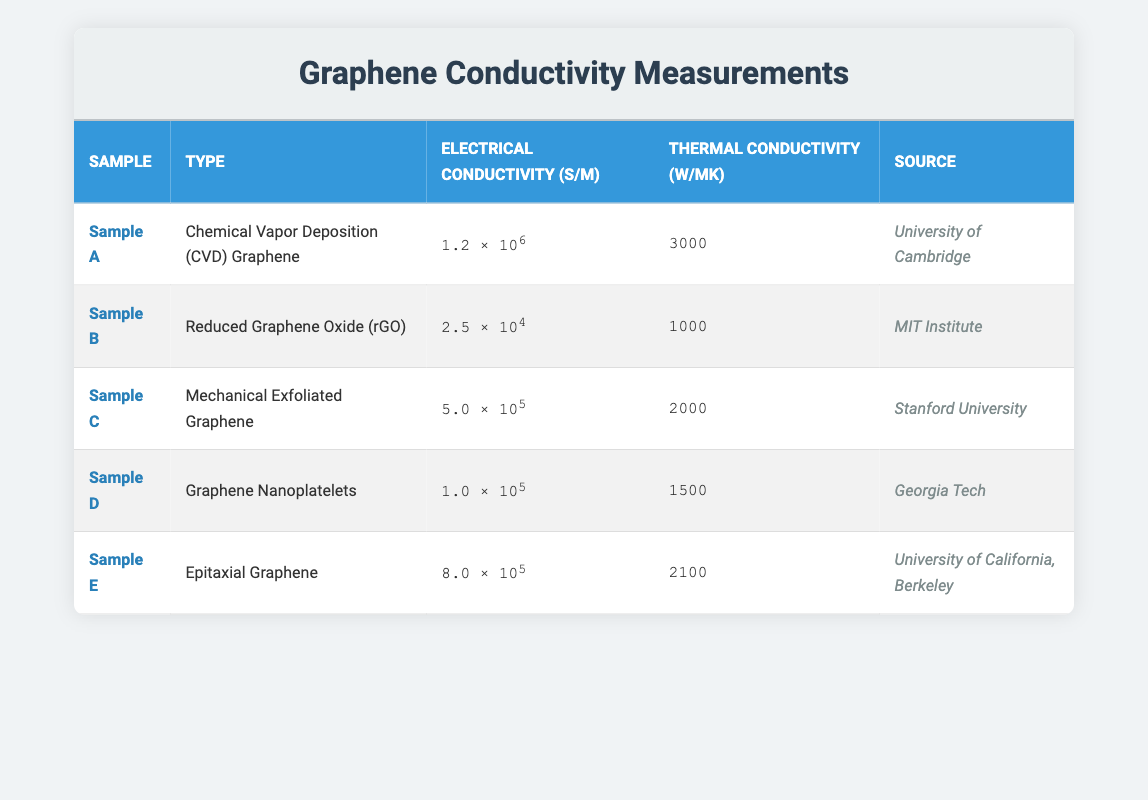What is the electrical conductivity of Sample A? The table shows the electrical conductivity value for Sample A listed as "1.2 × 10⁶ S/m."
Answer: 1.2 × 10⁶ S/m Which sample has the highest thermal conductivity? By comparing the thermal conductivity values of all samples, Sample A has a value of 3000 W/mK, which is higher than the values of the other samples.
Answer: Sample A Is the electrical conductivity of Reduced Graphene Oxide greater than 1.0 × 10⁵ S/m? The table shows that the electrical conductivity for Reduced Graphene Oxide (Sample B) is 2.5 × 10⁴ S/m, which is less than 1.0 × 10⁵ S/m.
Answer: No What is the average electrical conductivity of all samples? To calculate the average, we sum the electrical conductivities: (1.2e6 + 2.5e4 + 5.0e5 + 1.0e5 + 8.0e5) = 2.42e6. There are 5 samples, so the average is 2.42e6 / 5 = 484000 S/m.
Answer: 484000 S/m Does any sample have both electrical conductivity and thermal conductivity above 2000? By checking the values, only Sample A has electrical conductivity of 1.2e6 S/m and thermal conductivity of 3000 W/mK, both above 2000.
Answer: Yes What is the difference in electrical conductivity between Epitaxial Graphene and Graphene Nanoplatelets? The electrical conductivity values are 8.0e5 S/m for Epitaxial Graphene (Sample E) and 1.0e5 S/m for Graphene Nanoplatelets (Sample D). The difference is 8.0e5 - 1.0e5 = 7.0e5 S/m.
Answer: 7.0e5 S/m Which sample has the lowest thermal conductivity and what is that value? Comparing all thermal conductivity values, Sample B (Reduced Graphene Oxide) has the lowest value of 1000 W/mK.
Answer: 1000 W/mK Among all samples, which one is sourced from the University of California, Berkeley? The table indicates that Sample E, Epitaxial Graphene, is sourced from the University of California, Berkeley.
Answer: Sample E What is the sum of the electrical conductivities of Sample C and Sample D? The electrical conductivity for Sample C (Mechanical Exfoliated Graphene) is 5.0e5 S/m and for Sample D (Graphene Nanoplatelets) it is 1.0e5 S/m. Therefore, the sum is 5.0e5 + 1.0e5 = 6.0e5 S/m.
Answer: 6.0e5 S/m 